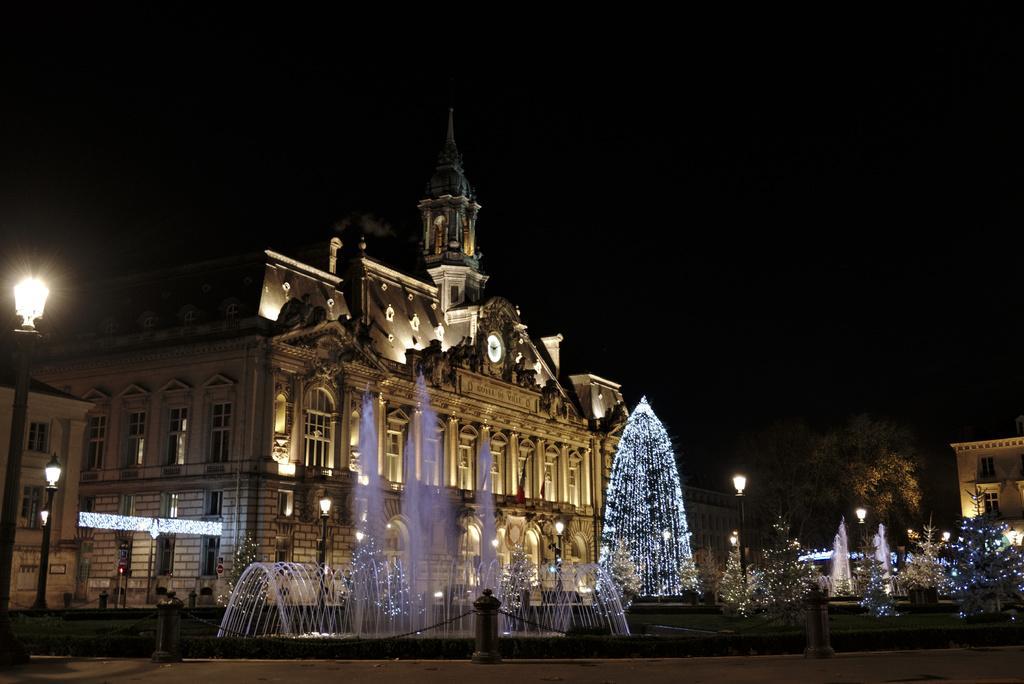Describe this image in one or two sentences. This is the picture of a building. In this image there is a fountain in the foreground. At the back there are buildings and trees and there is a clock on the wall. There are street lights and there is a railing around the fountain. At the top there is sky. At the bottom there is a road. 